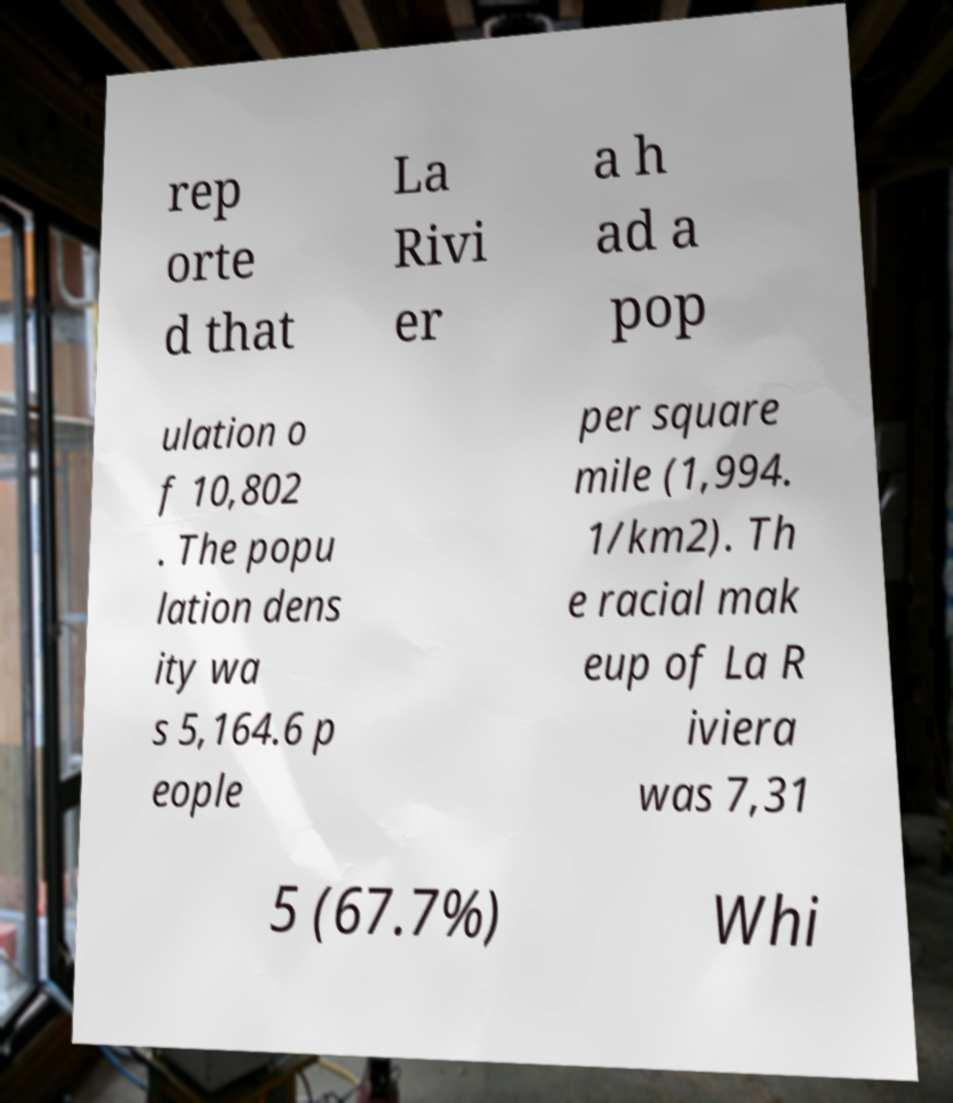Can you accurately transcribe the text from the provided image for me? rep orte d that La Rivi er a h ad a pop ulation o f 10,802 . The popu lation dens ity wa s 5,164.6 p eople per square mile (1,994. 1/km2). Th e racial mak eup of La R iviera was 7,31 5 (67.7%) Whi 